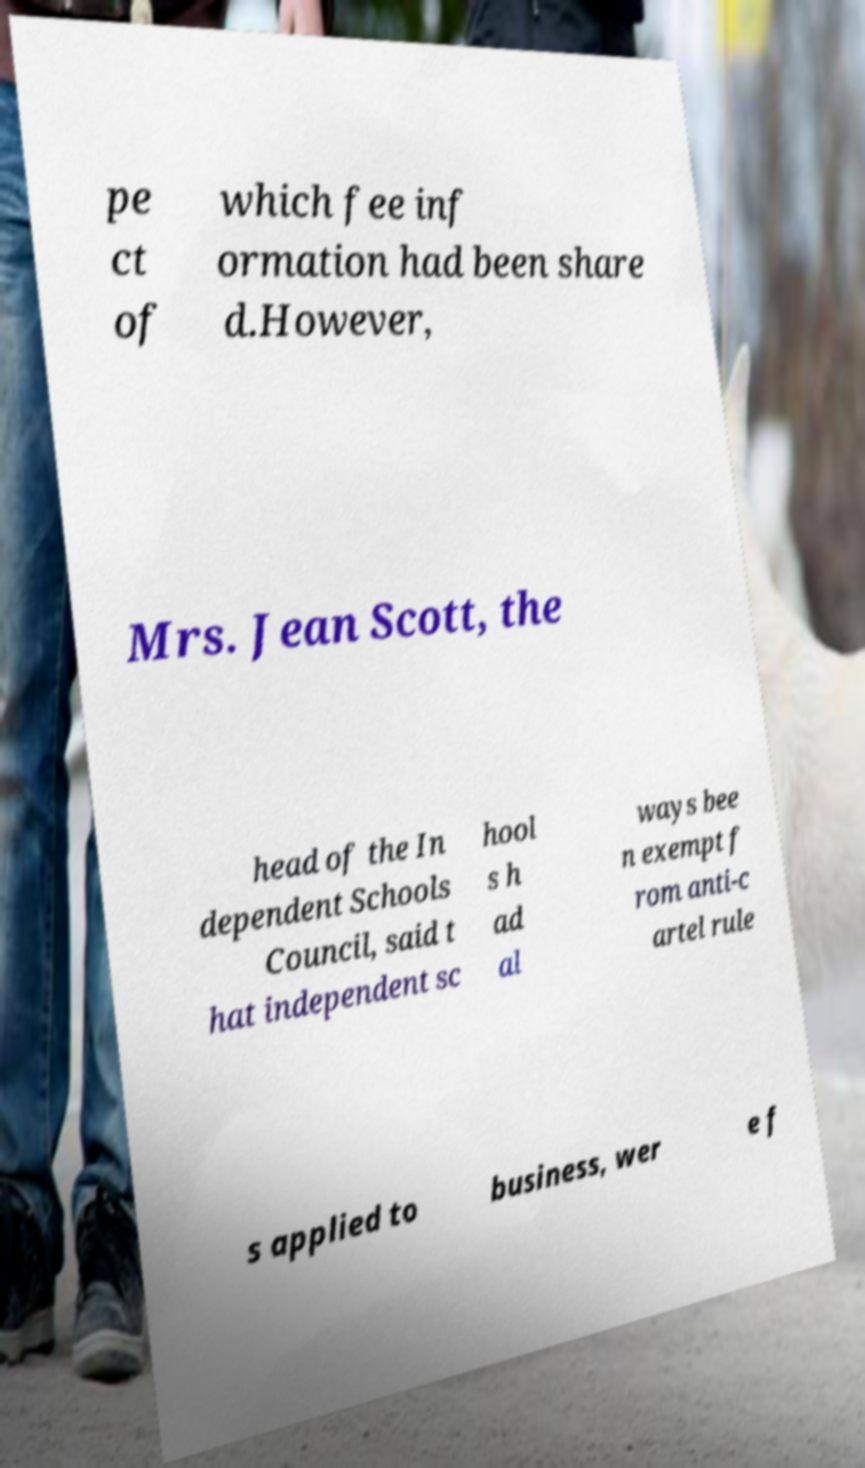What messages or text are displayed in this image? I need them in a readable, typed format. pe ct of which fee inf ormation had been share d.However, Mrs. Jean Scott, the head of the In dependent Schools Council, said t hat independent sc hool s h ad al ways bee n exempt f rom anti-c artel rule s applied to business, wer e f 